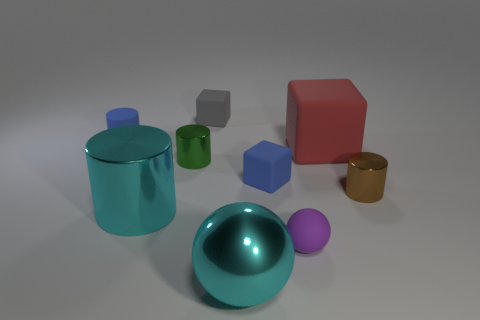There is a cylinder that is the same size as the red cube; what material is it?
Your answer should be compact. Metal. How many things are either big things to the left of the gray rubber cube or tiny objects that are in front of the tiny blue rubber cube?
Give a very brief answer. 3. The blue object that is made of the same material as the small blue cylinder is what size?
Your answer should be compact. Small. How many matte objects are gray cubes or gray spheres?
Your answer should be very brief. 1. How big is the red rubber object?
Ensure brevity in your answer.  Large. Do the gray matte object and the shiny ball have the same size?
Give a very brief answer. No. What material is the object in front of the small purple object?
Your response must be concise. Metal. There is a big object that is the same shape as the tiny purple thing; what is its material?
Your response must be concise. Metal. There is a tiny blue rubber thing behind the large matte thing; are there any red rubber objects behind it?
Provide a short and direct response. No. Is the small purple matte thing the same shape as the green metallic thing?
Give a very brief answer. No. 